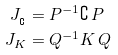<formula> <loc_0><loc_0><loc_500><loc_500>J _ { _ { \complement } } & = P ^ { - 1 } \complement \, P \\ J _ { K } & = Q ^ { - 1 } K \, Q</formula> 